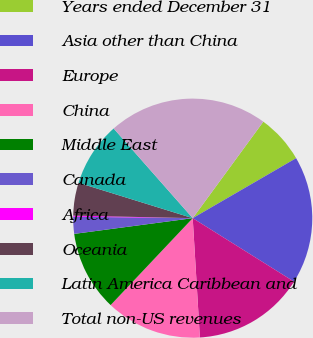<chart> <loc_0><loc_0><loc_500><loc_500><pie_chart><fcel>Years ended December 31<fcel>Asia other than China<fcel>Europe<fcel>China<fcel>Middle East<fcel>Canada<fcel>Africa<fcel>Oceania<fcel>Latin America Caribbean and<fcel>Total non-US revenues<nl><fcel>6.58%<fcel>17.28%<fcel>15.14%<fcel>13.0%<fcel>10.86%<fcel>2.29%<fcel>0.15%<fcel>4.44%<fcel>8.72%<fcel>21.56%<nl></chart> 